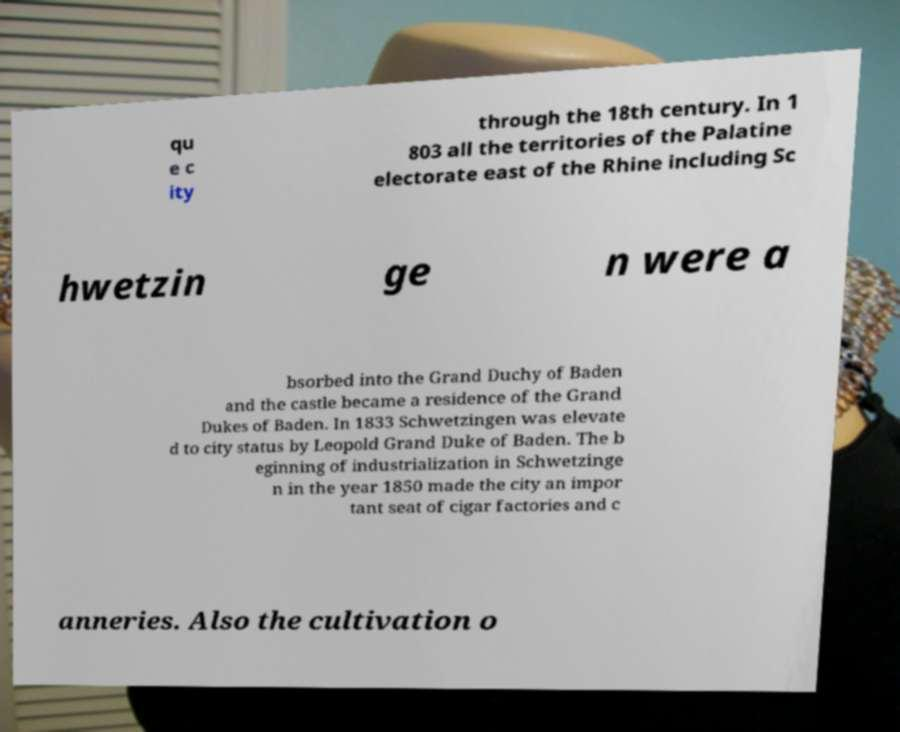I need the written content from this picture converted into text. Can you do that? qu e c ity through the 18th century. In 1 803 all the territories of the Palatine electorate east of the Rhine including Sc hwetzin ge n were a bsorbed into the Grand Duchy of Baden and the castle became a residence of the Grand Dukes of Baden. In 1833 Schwetzingen was elevate d to city status by Leopold Grand Duke of Baden. The b eginning of industrialization in Schwetzinge n in the year 1850 made the city an impor tant seat of cigar factories and c anneries. Also the cultivation o 